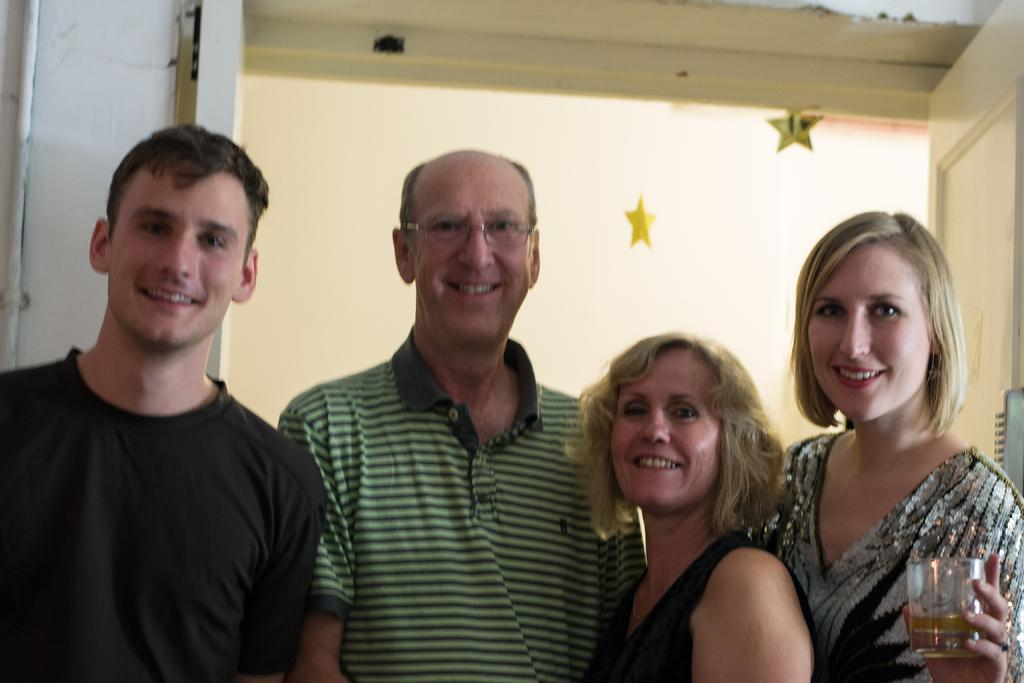What are the people in the image doing? The people in the image are standing and smiling. How can you describe the clothing of the people in the image? The people are wearing different color dresses. Can you identify any objects being held by the people in the image? One person is holding a glass. What can be seen in the background of the image? There is a door visible in the background, and there are two yellow stars. How many trees can be seen in the image? There are no trees visible in the image. What type of finger is being used to point at the stars in the image? There is no finger pointing at the stars in the image, as there are no stars being pointed at. 